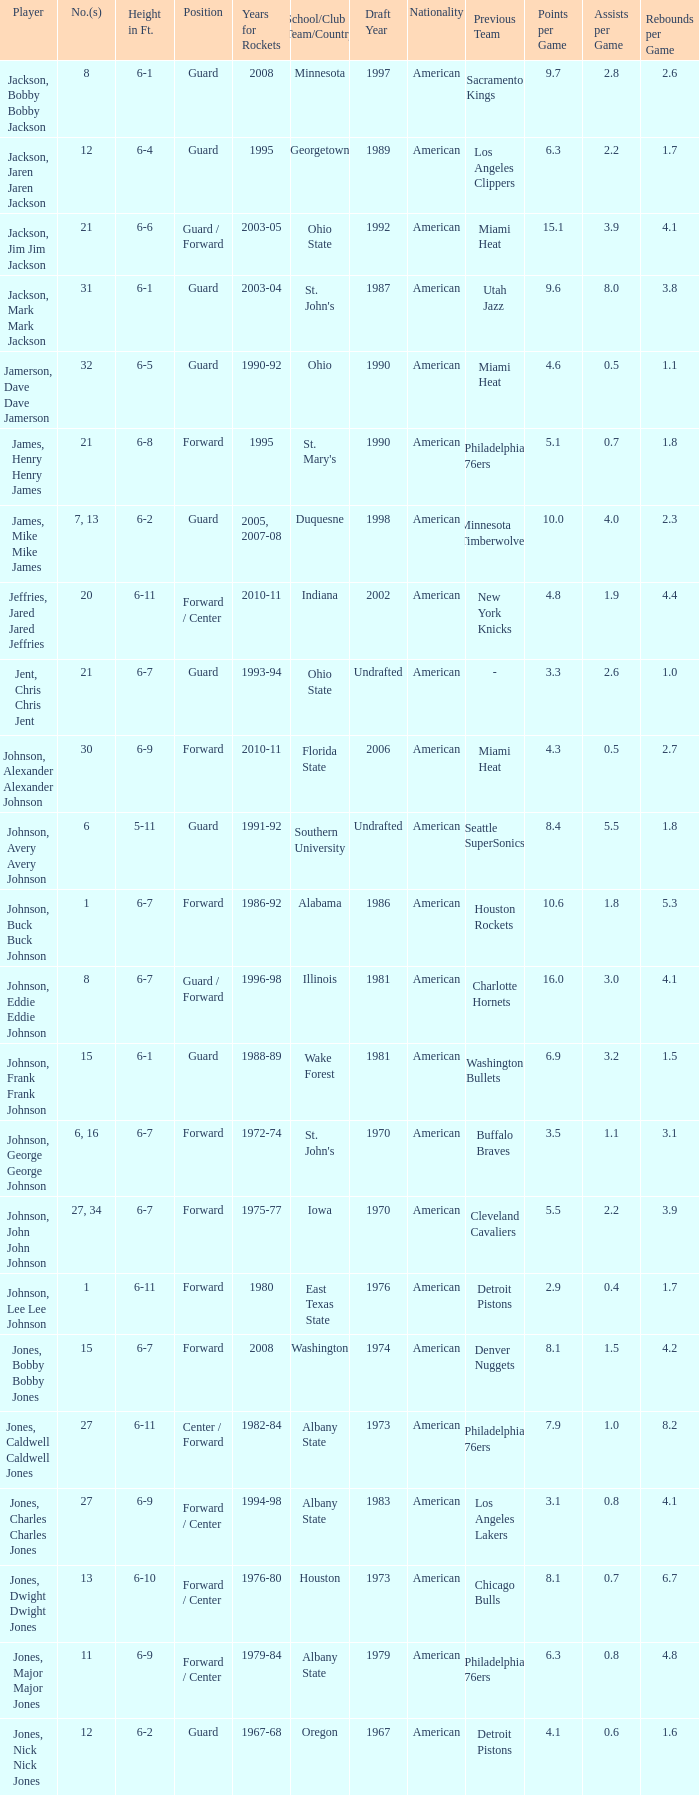Which player who played for the Rockets for the years 1986-92? Johnson, Buck Buck Johnson. 